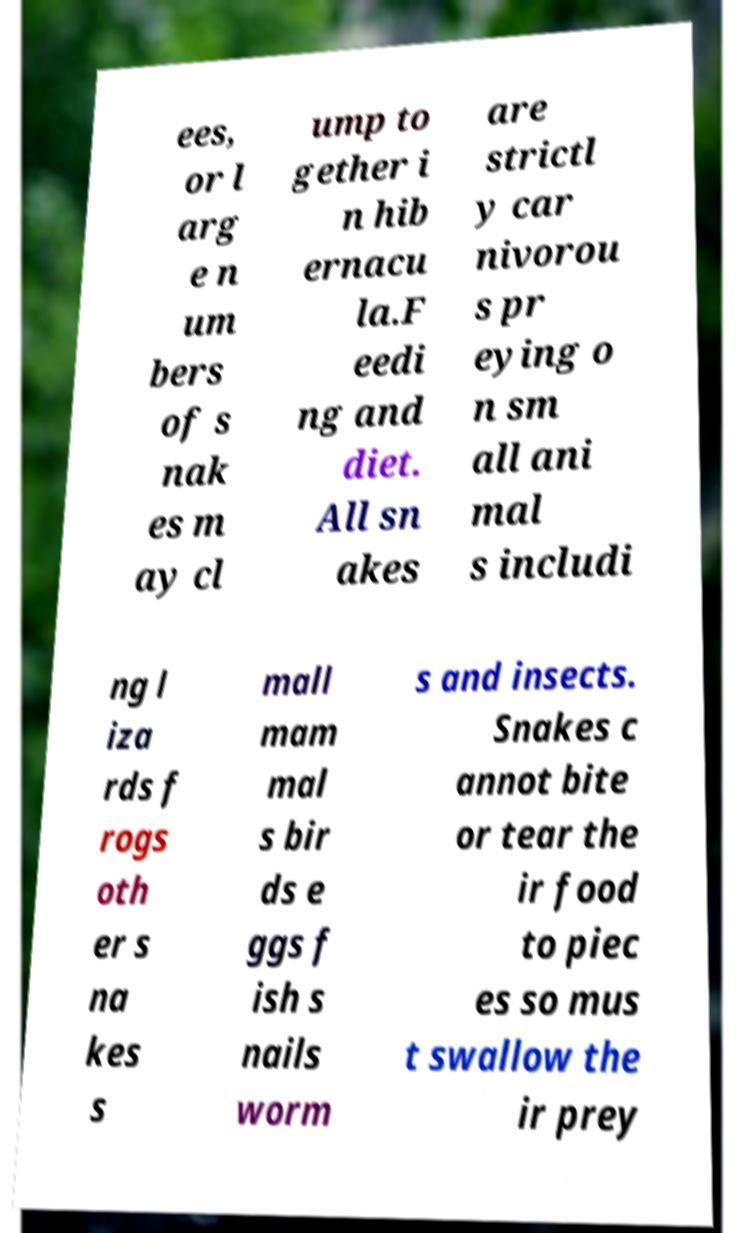What messages or text are displayed in this image? I need them in a readable, typed format. ees, or l arg e n um bers of s nak es m ay cl ump to gether i n hib ernacu la.F eedi ng and diet. All sn akes are strictl y car nivorou s pr eying o n sm all ani mal s includi ng l iza rds f rogs oth er s na kes s mall mam mal s bir ds e ggs f ish s nails worm s and insects. Snakes c annot bite or tear the ir food to piec es so mus t swallow the ir prey 